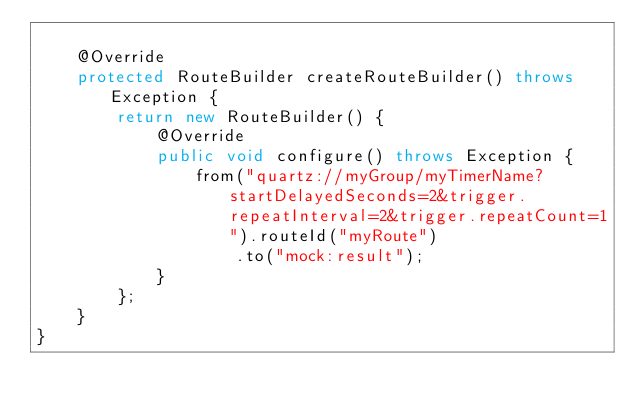<code> <loc_0><loc_0><loc_500><loc_500><_Java_>
    @Override
    protected RouteBuilder createRouteBuilder() throws Exception {
        return new RouteBuilder() {
            @Override
            public void configure() throws Exception {
                from("quartz://myGroup/myTimerName?startDelayedSeconds=2&trigger.repeatInterval=2&trigger.repeatCount=1").routeId("myRoute")
                    .to("mock:result");
            }
        };
    }
}
</code> 